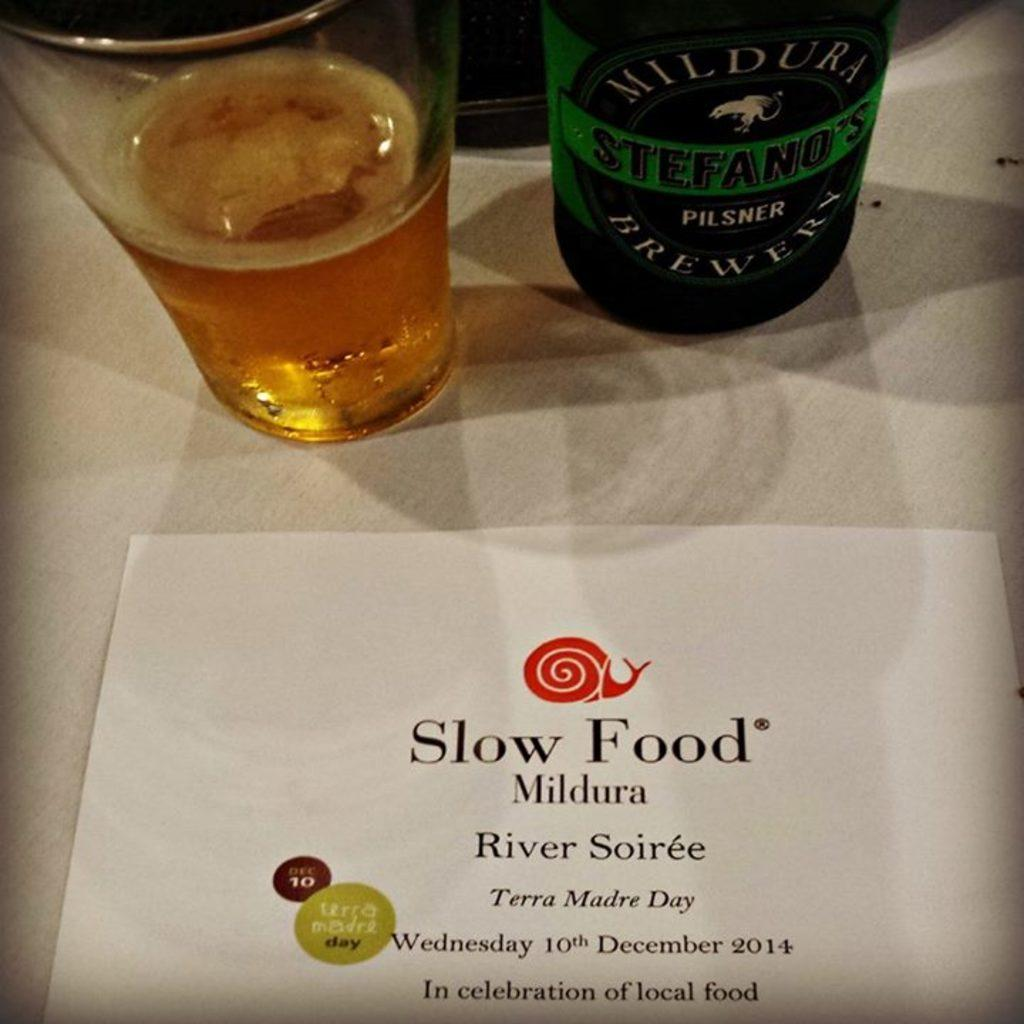<image>
Summarize the visual content of the image. the words slow food are on the paper 